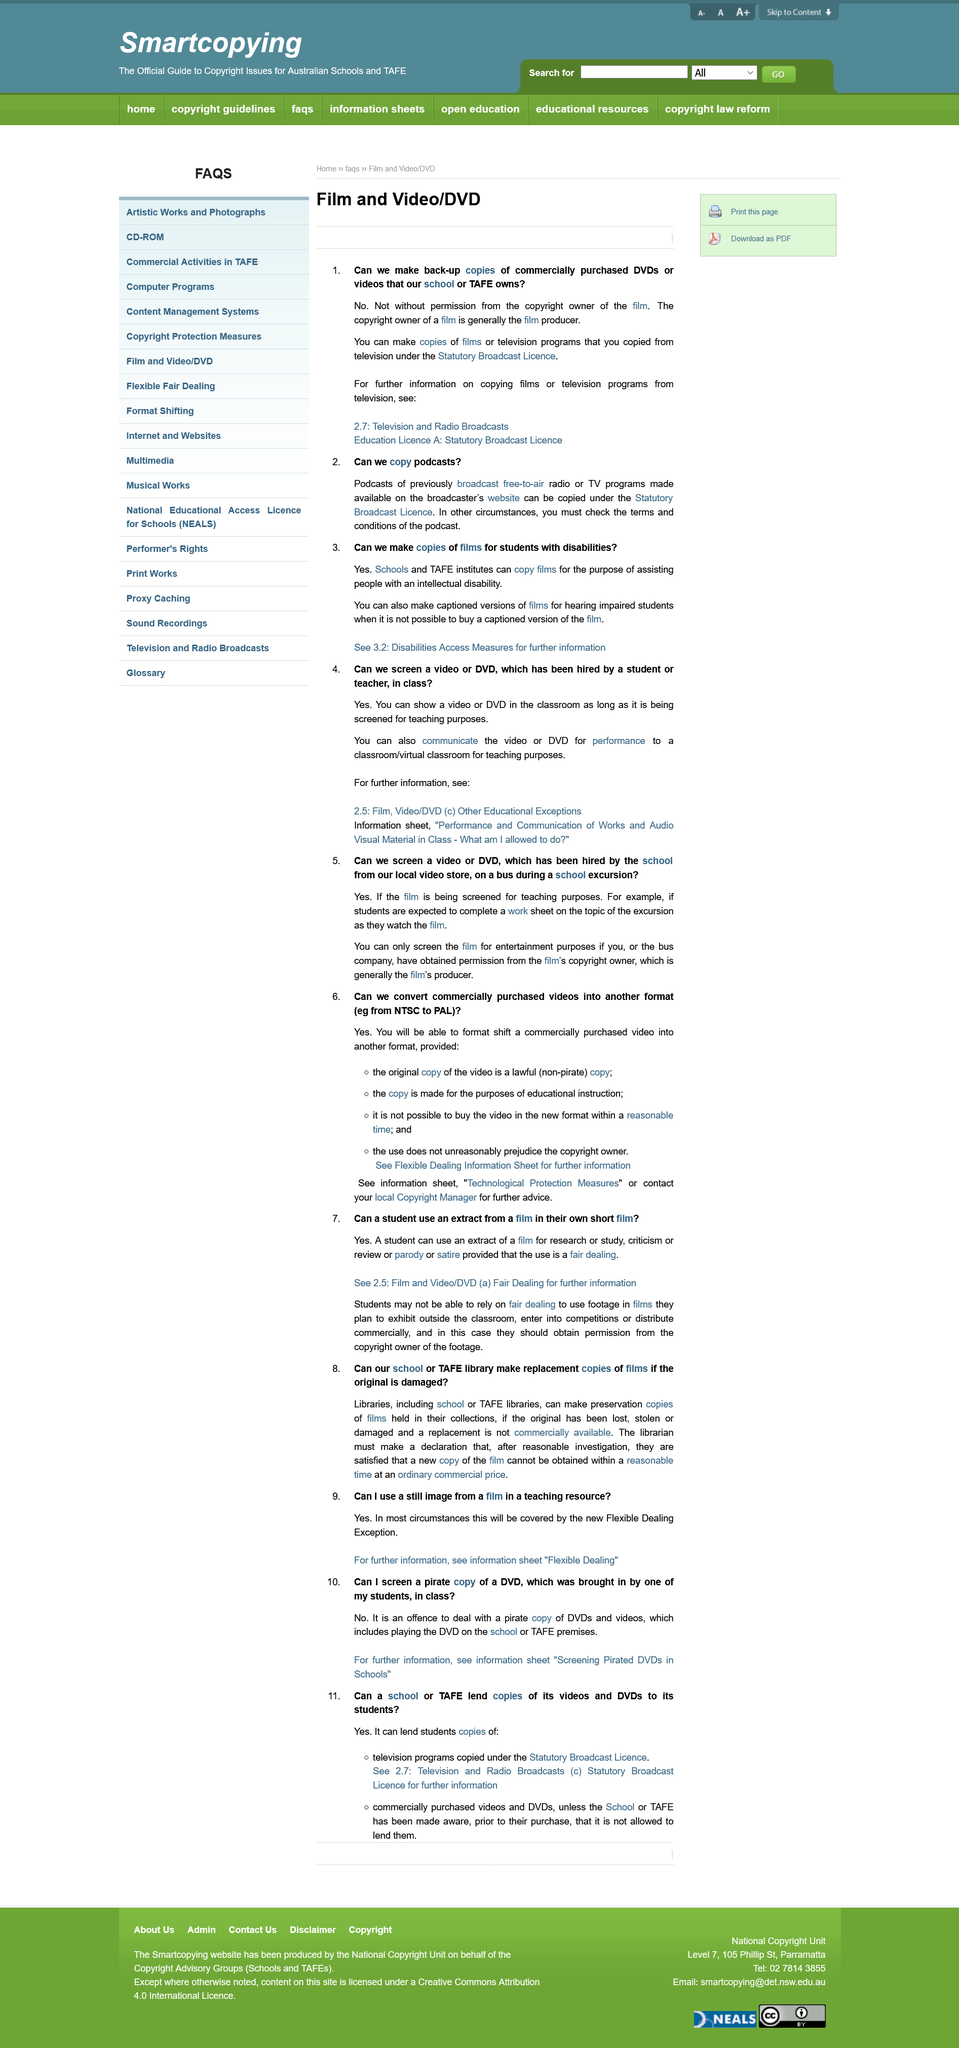List a handful of essential elements in this visual. Yes, a still image from a film can be used in a teaching resource in most circumstances. It is not permissible for a school to screen a video hired for entertainment purposes during a school excursion on a bus, unless the film's copyright owner has granted permission to the school or the bus company. It is permissible to create copies of films for students with disabilities. Yes, a student can use an extract from a film in their short film as long as the use is considered fair dealing. Yes, a DVD hired by a student can be screened in class, for teaching purposes only. 